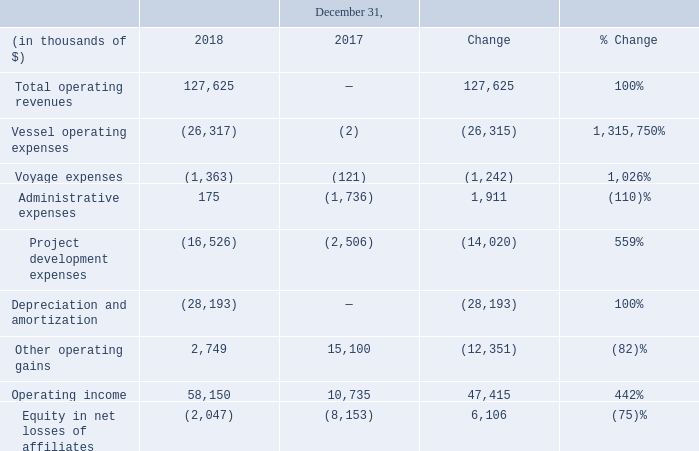FLNG segment
Total operating revenues: On May 31, 2018, the Hilli was accepted by the Customer and, accordingly, commenced operations. As a result, she generated $127.6 million total operating revenues in relation to her liquefaction services for the year ended December 31, 2018.
Vessel operating expenses: This represents the vessel operating expenses incurred by the Hilli since she commenced operations.
Project development expenses: This relates to non-capitalized project-related expenses comprising of legal, professional and consultancy costs. The increase for the twelve months ended December 31, 2018 was primarily as a result of increased engineering consultation fees and front-end engineering and design costs in relation to the Gimi GTA project.
Depreciation: Subsequent to the Customer's acceptance of the Hilli, we determined her to be operational and, therefore, depreciation commenced during the second quarter of 2018.
Other operating gains: Includes the realized and unrealized gain on the oil derivative instrument. In 2018, we recognized a realized gain of $26.7 million, and an unrealized fair value loss of $10.0 million, relating to the LTA oil derivative instrument as a result of the increased price of Brent Crude during the year. The derivative asset was recognized upon the LTA becoming effective in December 2017. In 2017, we recognized an unrealized fair value gain of $15.1 million.
For the year ended December 31, 2018, this is partially offset by a $1.3 million write off of capitalized conversion costs in relation to the Gandria. In addition, subsequent to the decision to wind down OneLNG, we wrote off $12.7 million of the trading balance with OneLNG as we deem it to be no longer recoverable.
Equity in net losses of affiliates: Pursuant to the formation of OneLNG in July 2016, we equity account for our share of net losses in OneLNG. Given the difficulties in finalizing an attractive debt financing package along with other capital and resource priorities, in April 2018, Golar and Schlumberger decided to wind down OneLNG and work on FLNG projects as required on a case-by-case basis. As a result, activity levels have been substantially reduced for the year ended December 31, 2018 and the carrying value of the investment was written down to $nil.
Why did the activity levels decrease in 2018? Golar and schlumberger decided to wind down onelng and work on flng projects as required on a case-by-case basis. What was the realized gain on the oil derivative instrument? $26.7 million. What are the different components of expenses? Vessel operating expenses, voyage expenses, administrative expenses, project development expenses, depreciation and amortization. In which year was the project development expenses higher? (16,526) > (2,506)
Answer: 2018. What was the change in total operating revenues between 2017 and 2018?
Answer scale should be: thousand. 127,625 - 0 
Answer: 127625. What was the percentage change in operating income between 2017 and 2018?
Answer scale should be: percent. (58,150 - 10,735)/10,735 
Answer: 441.69. 